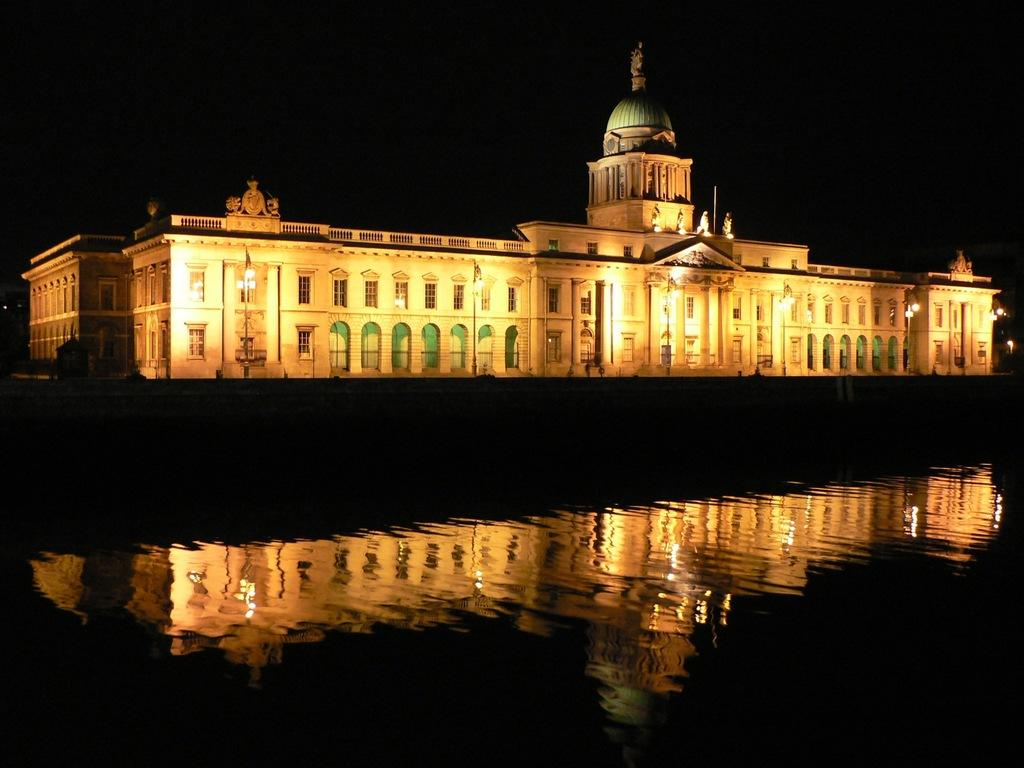What type of structure is present in the image? There is a building in the image. Are there any additional features associated with the building? Yes, there are lights associated with the building. What can be seen in the water in the image? The water in the image has a reflection of the building. How much does the daughter weigh in the image? There is no daughter present in the image, so it is not possible to determine her weight. 